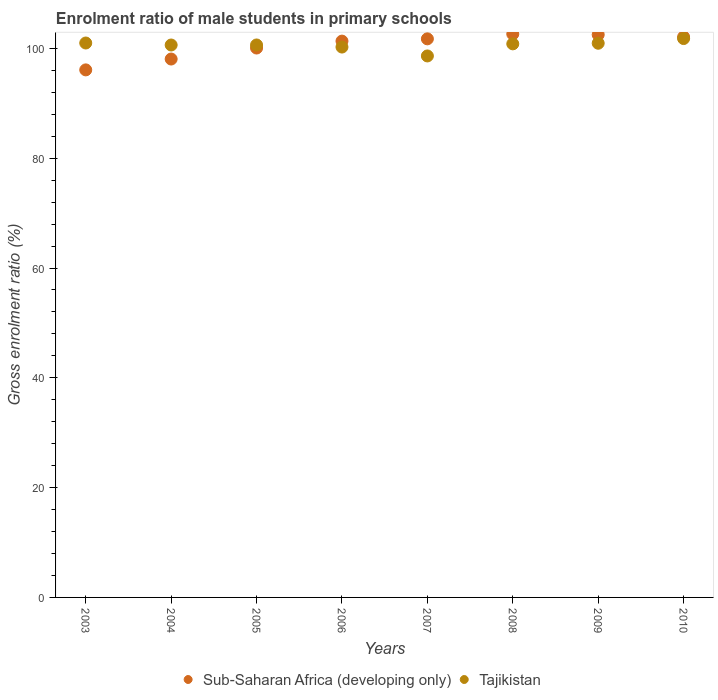How many different coloured dotlines are there?
Provide a succinct answer. 2. Is the number of dotlines equal to the number of legend labels?
Offer a very short reply. Yes. What is the enrolment ratio of male students in primary schools in Tajikistan in 2006?
Provide a short and direct response. 100.25. Across all years, what is the maximum enrolment ratio of male students in primary schools in Sub-Saharan Africa (developing only)?
Ensure brevity in your answer.  102.62. Across all years, what is the minimum enrolment ratio of male students in primary schools in Tajikistan?
Your answer should be compact. 98.63. In which year was the enrolment ratio of male students in primary schools in Sub-Saharan Africa (developing only) maximum?
Your answer should be compact. 2008. In which year was the enrolment ratio of male students in primary schools in Sub-Saharan Africa (developing only) minimum?
Make the answer very short. 2003. What is the total enrolment ratio of male students in primary schools in Tajikistan in the graph?
Provide a succinct answer. 804.71. What is the difference between the enrolment ratio of male students in primary schools in Tajikistan in 2006 and that in 2009?
Your answer should be compact. -0.69. What is the difference between the enrolment ratio of male students in primary schools in Tajikistan in 2003 and the enrolment ratio of male students in primary schools in Sub-Saharan Africa (developing only) in 2008?
Keep it short and to the point. -1.63. What is the average enrolment ratio of male students in primary schools in Sub-Saharan Africa (developing only) per year?
Make the answer very short. 100.57. In the year 2005, what is the difference between the enrolment ratio of male students in primary schools in Sub-Saharan Africa (developing only) and enrolment ratio of male students in primary schools in Tajikistan?
Your answer should be very brief. -0.56. What is the ratio of the enrolment ratio of male students in primary schools in Sub-Saharan Africa (developing only) in 2005 to that in 2008?
Ensure brevity in your answer.  0.98. Is the difference between the enrolment ratio of male students in primary schools in Sub-Saharan Africa (developing only) in 2006 and 2009 greater than the difference between the enrolment ratio of male students in primary schools in Tajikistan in 2006 and 2009?
Ensure brevity in your answer.  No. What is the difference between the highest and the second highest enrolment ratio of male students in primary schools in Tajikistan?
Your answer should be very brief. 0.81. What is the difference between the highest and the lowest enrolment ratio of male students in primary schools in Sub-Saharan Africa (developing only)?
Your answer should be very brief. 6.53. Does the enrolment ratio of male students in primary schools in Sub-Saharan Africa (developing only) monotonically increase over the years?
Your response must be concise. No. Is the enrolment ratio of male students in primary schools in Sub-Saharan Africa (developing only) strictly greater than the enrolment ratio of male students in primary schools in Tajikistan over the years?
Give a very brief answer. No. Is the enrolment ratio of male students in primary schools in Sub-Saharan Africa (developing only) strictly less than the enrolment ratio of male students in primary schools in Tajikistan over the years?
Provide a succinct answer. No. How many dotlines are there?
Ensure brevity in your answer.  2. Does the graph contain any zero values?
Offer a terse response. No. Does the graph contain grids?
Make the answer very short. No. Where does the legend appear in the graph?
Offer a terse response. Bottom center. How are the legend labels stacked?
Offer a very short reply. Horizontal. What is the title of the graph?
Offer a terse response. Enrolment ratio of male students in primary schools. Does "Rwanda" appear as one of the legend labels in the graph?
Offer a very short reply. No. What is the label or title of the Y-axis?
Your response must be concise. Gross enrolment ratio (%). What is the Gross enrolment ratio (%) of Sub-Saharan Africa (developing only) in 2003?
Your response must be concise. 96.09. What is the Gross enrolment ratio (%) in Tajikistan in 2003?
Offer a terse response. 100.99. What is the Gross enrolment ratio (%) in Sub-Saharan Africa (developing only) in 2004?
Provide a succinct answer. 98.07. What is the Gross enrolment ratio (%) of Tajikistan in 2004?
Your answer should be compact. 100.63. What is the Gross enrolment ratio (%) of Sub-Saharan Africa (developing only) in 2005?
Provide a succinct answer. 100.07. What is the Gross enrolment ratio (%) in Tajikistan in 2005?
Your response must be concise. 100.63. What is the Gross enrolment ratio (%) of Sub-Saharan Africa (developing only) in 2006?
Give a very brief answer. 101.33. What is the Gross enrolment ratio (%) in Tajikistan in 2006?
Offer a terse response. 100.25. What is the Gross enrolment ratio (%) of Sub-Saharan Africa (developing only) in 2007?
Ensure brevity in your answer.  101.75. What is the Gross enrolment ratio (%) in Tajikistan in 2007?
Provide a succinct answer. 98.63. What is the Gross enrolment ratio (%) in Sub-Saharan Africa (developing only) in 2008?
Your answer should be compact. 102.62. What is the Gross enrolment ratio (%) of Tajikistan in 2008?
Offer a very short reply. 100.83. What is the Gross enrolment ratio (%) in Sub-Saharan Africa (developing only) in 2009?
Your answer should be very brief. 102.5. What is the Gross enrolment ratio (%) in Tajikistan in 2009?
Give a very brief answer. 100.95. What is the Gross enrolment ratio (%) in Sub-Saharan Africa (developing only) in 2010?
Give a very brief answer. 102.08. What is the Gross enrolment ratio (%) in Tajikistan in 2010?
Make the answer very short. 101.8. Across all years, what is the maximum Gross enrolment ratio (%) in Sub-Saharan Africa (developing only)?
Provide a short and direct response. 102.62. Across all years, what is the maximum Gross enrolment ratio (%) in Tajikistan?
Offer a terse response. 101.8. Across all years, what is the minimum Gross enrolment ratio (%) of Sub-Saharan Africa (developing only)?
Keep it short and to the point. 96.09. Across all years, what is the minimum Gross enrolment ratio (%) in Tajikistan?
Offer a terse response. 98.63. What is the total Gross enrolment ratio (%) of Sub-Saharan Africa (developing only) in the graph?
Provide a short and direct response. 804.52. What is the total Gross enrolment ratio (%) of Tajikistan in the graph?
Make the answer very short. 804.71. What is the difference between the Gross enrolment ratio (%) of Sub-Saharan Africa (developing only) in 2003 and that in 2004?
Your response must be concise. -1.98. What is the difference between the Gross enrolment ratio (%) in Tajikistan in 2003 and that in 2004?
Offer a terse response. 0.36. What is the difference between the Gross enrolment ratio (%) of Sub-Saharan Africa (developing only) in 2003 and that in 2005?
Keep it short and to the point. -3.98. What is the difference between the Gross enrolment ratio (%) of Tajikistan in 2003 and that in 2005?
Your answer should be very brief. 0.36. What is the difference between the Gross enrolment ratio (%) in Sub-Saharan Africa (developing only) in 2003 and that in 2006?
Your answer should be compact. -5.24. What is the difference between the Gross enrolment ratio (%) of Tajikistan in 2003 and that in 2006?
Keep it short and to the point. 0.74. What is the difference between the Gross enrolment ratio (%) of Sub-Saharan Africa (developing only) in 2003 and that in 2007?
Ensure brevity in your answer.  -5.65. What is the difference between the Gross enrolment ratio (%) in Tajikistan in 2003 and that in 2007?
Provide a short and direct response. 2.36. What is the difference between the Gross enrolment ratio (%) of Sub-Saharan Africa (developing only) in 2003 and that in 2008?
Offer a terse response. -6.53. What is the difference between the Gross enrolment ratio (%) of Tajikistan in 2003 and that in 2008?
Provide a short and direct response. 0.15. What is the difference between the Gross enrolment ratio (%) of Sub-Saharan Africa (developing only) in 2003 and that in 2009?
Give a very brief answer. -6.41. What is the difference between the Gross enrolment ratio (%) of Tajikistan in 2003 and that in 2009?
Offer a very short reply. 0.04. What is the difference between the Gross enrolment ratio (%) of Sub-Saharan Africa (developing only) in 2003 and that in 2010?
Make the answer very short. -5.99. What is the difference between the Gross enrolment ratio (%) in Tajikistan in 2003 and that in 2010?
Keep it short and to the point. -0.81. What is the difference between the Gross enrolment ratio (%) in Sub-Saharan Africa (developing only) in 2004 and that in 2005?
Provide a succinct answer. -2. What is the difference between the Gross enrolment ratio (%) in Tajikistan in 2004 and that in 2005?
Your answer should be very brief. -0.01. What is the difference between the Gross enrolment ratio (%) of Sub-Saharan Africa (developing only) in 2004 and that in 2006?
Your answer should be compact. -3.26. What is the difference between the Gross enrolment ratio (%) in Tajikistan in 2004 and that in 2006?
Offer a terse response. 0.37. What is the difference between the Gross enrolment ratio (%) in Sub-Saharan Africa (developing only) in 2004 and that in 2007?
Your answer should be very brief. -3.68. What is the difference between the Gross enrolment ratio (%) of Tajikistan in 2004 and that in 2007?
Give a very brief answer. 1.99. What is the difference between the Gross enrolment ratio (%) of Sub-Saharan Africa (developing only) in 2004 and that in 2008?
Keep it short and to the point. -4.55. What is the difference between the Gross enrolment ratio (%) of Tajikistan in 2004 and that in 2008?
Your response must be concise. -0.21. What is the difference between the Gross enrolment ratio (%) in Sub-Saharan Africa (developing only) in 2004 and that in 2009?
Make the answer very short. -4.43. What is the difference between the Gross enrolment ratio (%) in Tajikistan in 2004 and that in 2009?
Provide a succinct answer. -0.32. What is the difference between the Gross enrolment ratio (%) in Sub-Saharan Africa (developing only) in 2004 and that in 2010?
Offer a terse response. -4.01. What is the difference between the Gross enrolment ratio (%) of Tajikistan in 2004 and that in 2010?
Give a very brief answer. -1.17. What is the difference between the Gross enrolment ratio (%) of Sub-Saharan Africa (developing only) in 2005 and that in 2006?
Your answer should be very brief. -1.26. What is the difference between the Gross enrolment ratio (%) of Tajikistan in 2005 and that in 2006?
Provide a succinct answer. 0.38. What is the difference between the Gross enrolment ratio (%) of Sub-Saharan Africa (developing only) in 2005 and that in 2007?
Give a very brief answer. -1.67. What is the difference between the Gross enrolment ratio (%) of Tajikistan in 2005 and that in 2007?
Your answer should be very brief. 2. What is the difference between the Gross enrolment ratio (%) of Sub-Saharan Africa (developing only) in 2005 and that in 2008?
Your response must be concise. -2.55. What is the difference between the Gross enrolment ratio (%) of Tajikistan in 2005 and that in 2008?
Your response must be concise. -0.2. What is the difference between the Gross enrolment ratio (%) of Sub-Saharan Africa (developing only) in 2005 and that in 2009?
Offer a terse response. -2.43. What is the difference between the Gross enrolment ratio (%) of Tajikistan in 2005 and that in 2009?
Offer a very short reply. -0.31. What is the difference between the Gross enrolment ratio (%) in Sub-Saharan Africa (developing only) in 2005 and that in 2010?
Provide a succinct answer. -2.01. What is the difference between the Gross enrolment ratio (%) of Tajikistan in 2005 and that in 2010?
Provide a short and direct response. -1.17. What is the difference between the Gross enrolment ratio (%) of Sub-Saharan Africa (developing only) in 2006 and that in 2007?
Give a very brief answer. -0.41. What is the difference between the Gross enrolment ratio (%) in Tajikistan in 2006 and that in 2007?
Your answer should be compact. 1.62. What is the difference between the Gross enrolment ratio (%) in Sub-Saharan Africa (developing only) in 2006 and that in 2008?
Give a very brief answer. -1.29. What is the difference between the Gross enrolment ratio (%) of Tajikistan in 2006 and that in 2008?
Give a very brief answer. -0.58. What is the difference between the Gross enrolment ratio (%) in Sub-Saharan Africa (developing only) in 2006 and that in 2009?
Provide a short and direct response. -1.17. What is the difference between the Gross enrolment ratio (%) of Tajikistan in 2006 and that in 2009?
Make the answer very short. -0.69. What is the difference between the Gross enrolment ratio (%) in Sub-Saharan Africa (developing only) in 2006 and that in 2010?
Provide a succinct answer. -0.75. What is the difference between the Gross enrolment ratio (%) of Tajikistan in 2006 and that in 2010?
Give a very brief answer. -1.55. What is the difference between the Gross enrolment ratio (%) in Sub-Saharan Africa (developing only) in 2007 and that in 2008?
Make the answer very short. -0.88. What is the difference between the Gross enrolment ratio (%) in Tajikistan in 2007 and that in 2008?
Give a very brief answer. -2.2. What is the difference between the Gross enrolment ratio (%) of Sub-Saharan Africa (developing only) in 2007 and that in 2009?
Offer a terse response. -0.76. What is the difference between the Gross enrolment ratio (%) in Tajikistan in 2007 and that in 2009?
Offer a very short reply. -2.31. What is the difference between the Gross enrolment ratio (%) of Sub-Saharan Africa (developing only) in 2007 and that in 2010?
Offer a terse response. -0.33. What is the difference between the Gross enrolment ratio (%) of Tajikistan in 2007 and that in 2010?
Keep it short and to the point. -3.17. What is the difference between the Gross enrolment ratio (%) in Sub-Saharan Africa (developing only) in 2008 and that in 2009?
Offer a very short reply. 0.12. What is the difference between the Gross enrolment ratio (%) in Tajikistan in 2008 and that in 2009?
Ensure brevity in your answer.  -0.11. What is the difference between the Gross enrolment ratio (%) of Sub-Saharan Africa (developing only) in 2008 and that in 2010?
Ensure brevity in your answer.  0.54. What is the difference between the Gross enrolment ratio (%) of Tajikistan in 2008 and that in 2010?
Provide a succinct answer. -0.97. What is the difference between the Gross enrolment ratio (%) in Sub-Saharan Africa (developing only) in 2009 and that in 2010?
Provide a succinct answer. 0.42. What is the difference between the Gross enrolment ratio (%) of Tajikistan in 2009 and that in 2010?
Keep it short and to the point. -0.85. What is the difference between the Gross enrolment ratio (%) in Sub-Saharan Africa (developing only) in 2003 and the Gross enrolment ratio (%) in Tajikistan in 2004?
Your response must be concise. -4.53. What is the difference between the Gross enrolment ratio (%) in Sub-Saharan Africa (developing only) in 2003 and the Gross enrolment ratio (%) in Tajikistan in 2005?
Keep it short and to the point. -4.54. What is the difference between the Gross enrolment ratio (%) in Sub-Saharan Africa (developing only) in 2003 and the Gross enrolment ratio (%) in Tajikistan in 2006?
Offer a very short reply. -4.16. What is the difference between the Gross enrolment ratio (%) of Sub-Saharan Africa (developing only) in 2003 and the Gross enrolment ratio (%) of Tajikistan in 2007?
Your answer should be very brief. -2.54. What is the difference between the Gross enrolment ratio (%) in Sub-Saharan Africa (developing only) in 2003 and the Gross enrolment ratio (%) in Tajikistan in 2008?
Provide a short and direct response. -4.74. What is the difference between the Gross enrolment ratio (%) in Sub-Saharan Africa (developing only) in 2003 and the Gross enrolment ratio (%) in Tajikistan in 2009?
Keep it short and to the point. -4.85. What is the difference between the Gross enrolment ratio (%) of Sub-Saharan Africa (developing only) in 2003 and the Gross enrolment ratio (%) of Tajikistan in 2010?
Your answer should be compact. -5.71. What is the difference between the Gross enrolment ratio (%) in Sub-Saharan Africa (developing only) in 2004 and the Gross enrolment ratio (%) in Tajikistan in 2005?
Make the answer very short. -2.56. What is the difference between the Gross enrolment ratio (%) in Sub-Saharan Africa (developing only) in 2004 and the Gross enrolment ratio (%) in Tajikistan in 2006?
Provide a succinct answer. -2.18. What is the difference between the Gross enrolment ratio (%) in Sub-Saharan Africa (developing only) in 2004 and the Gross enrolment ratio (%) in Tajikistan in 2007?
Offer a very short reply. -0.56. What is the difference between the Gross enrolment ratio (%) of Sub-Saharan Africa (developing only) in 2004 and the Gross enrolment ratio (%) of Tajikistan in 2008?
Your response must be concise. -2.77. What is the difference between the Gross enrolment ratio (%) in Sub-Saharan Africa (developing only) in 2004 and the Gross enrolment ratio (%) in Tajikistan in 2009?
Your answer should be compact. -2.88. What is the difference between the Gross enrolment ratio (%) in Sub-Saharan Africa (developing only) in 2004 and the Gross enrolment ratio (%) in Tajikistan in 2010?
Your answer should be very brief. -3.73. What is the difference between the Gross enrolment ratio (%) of Sub-Saharan Africa (developing only) in 2005 and the Gross enrolment ratio (%) of Tajikistan in 2006?
Ensure brevity in your answer.  -0.18. What is the difference between the Gross enrolment ratio (%) in Sub-Saharan Africa (developing only) in 2005 and the Gross enrolment ratio (%) in Tajikistan in 2007?
Ensure brevity in your answer.  1.44. What is the difference between the Gross enrolment ratio (%) of Sub-Saharan Africa (developing only) in 2005 and the Gross enrolment ratio (%) of Tajikistan in 2008?
Your response must be concise. -0.76. What is the difference between the Gross enrolment ratio (%) in Sub-Saharan Africa (developing only) in 2005 and the Gross enrolment ratio (%) in Tajikistan in 2009?
Make the answer very short. -0.87. What is the difference between the Gross enrolment ratio (%) in Sub-Saharan Africa (developing only) in 2005 and the Gross enrolment ratio (%) in Tajikistan in 2010?
Make the answer very short. -1.73. What is the difference between the Gross enrolment ratio (%) of Sub-Saharan Africa (developing only) in 2006 and the Gross enrolment ratio (%) of Tajikistan in 2007?
Give a very brief answer. 2.7. What is the difference between the Gross enrolment ratio (%) of Sub-Saharan Africa (developing only) in 2006 and the Gross enrolment ratio (%) of Tajikistan in 2008?
Make the answer very short. 0.5. What is the difference between the Gross enrolment ratio (%) of Sub-Saharan Africa (developing only) in 2006 and the Gross enrolment ratio (%) of Tajikistan in 2009?
Provide a succinct answer. 0.39. What is the difference between the Gross enrolment ratio (%) of Sub-Saharan Africa (developing only) in 2006 and the Gross enrolment ratio (%) of Tajikistan in 2010?
Offer a terse response. -0.47. What is the difference between the Gross enrolment ratio (%) of Sub-Saharan Africa (developing only) in 2007 and the Gross enrolment ratio (%) of Tajikistan in 2008?
Ensure brevity in your answer.  0.91. What is the difference between the Gross enrolment ratio (%) in Sub-Saharan Africa (developing only) in 2007 and the Gross enrolment ratio (%) in Tajikistan in 2009?
Keep it short and to the point. 0.8. What is the difference between the Gross enrolment ratio (%) in Sub-Saharan Africa (developing only) in 2007 and the Gross enrolment ratio (%) in Tajikistan in 2010?
Provide a short and direct response. -0.05. What is the difference between the Gross enrolment ratio (%) in Sub-Saharan Africa (developing only) in 2008 and the Gross enrolment ratio (%) in Tajikistan in 2009?
Your answer should be very brief. 1.68. What is the difference between the Gross enrolment ratio (%) in Sub-Saharan Africa (developing only) in 2008 and the Gross enrolment ratio (%) in Tajikistan in 2010?
Your answer should be very brief. 0.82. What is the difference between the Gross enrolment ratio (%) of Sub-Saharan Africa (developing only) in 2009 and the Gross enrolment ratio (%) of Tajikistan in 2010?
Provide a short and direct response. 0.7. What is the average Gross enrolment ratio (%) in Sub-Saharan Africa (developing only) per year?
Your answer should be compact. 100.57. What is the average Gross enrolment ratio (%) in Tajikistan per year?
Your response must be concise. 100.59. In the year 2003, what is the difference between the Gross enrolment ratio (%) of Sub-Saharan Africa (developing only) and Gross enrolment ratio (%) of Tajikistan?
Keep it short and to the point. -4.89. In the year 2004, what is the difference between the Gross enrolment ratio (%) of Sub-Saharan Africa (developing only) and Gross enrolment ratio (%) of Tajikistan?
Keep it short and to the point. -2.56. In the year 2005, what is the difference between the Gross enrolment ratio (%) of Sub-Saharan Africa (developing only) and Gross enrolment ratio (%) of Tajikistan?
Keep it short and to the point. -0.56. In the year 2006, what is the difference between the Gross enrolment ratio (%) of Sub-Saharan Africa (developing only) and Gross enrolment ratio (%) of Tajikistan?
Offer a terse response. 1.08. In the year 2007, what is the difference between the Gross enrolment ratio (%) of Sub-Saharan Africa (developing only) and Gross enrolment ratio (%) of Tajikistan?
Keep it short and to the point. 3.12. In the year 2008, what is the difference between the Gross enrolment ratio (%) in Sub-Saharan Africa (developing only) and Gross enrolment ratio (%) in Tajikistan?
Provide a short and direct response. 1.79. In the year 2009, what is the difference between the Gross enrolment ratio (%) in Sub-Saharan Africa (developing only) and Gross enrolment ratio (%) in Tajikistan?
Offer a very short reply. 1.56. In the year 2010, what is the difference between the Gross enrolment ratio (%) in Sub-Saharan Africa (developing only) and Gross enrolment ratio (%) in Tajikistan?
Your answer should be compact. 0.28. What is the ratio of the Gross enrolment ratio (%) in Sub-Saharan Africa (developing only) in 2003 to that in 2004?
Ensure brevity in your answer.  0.98. What is the ratio of the Gross enrolment ratio (%) in Tajikistan in 2003 to that in 2004?
Offer a terse response. 1. What is the ratio of the Gross enrolment ratio (%) in Sub-Saharan Africa (developing only) in 2003 to that in 2005?
Offer a very short reply. 0.96. What is the ratio of the Gross enrolment ratio (%) in Sub-Saharan Africa (developing only) in 2003 to that in 2006?
Your answer should be compact. 0.95. What is the ratio of the Gross enrolment ratio (%) of Tajikistan in 2003 to that in 2006?
Ensure brevity in your answer.  1.01. What is the ratio of the Gross enrolment ratio (%) of Sub-Saharan Africa (developing only) in 2003 to that in 2007?
Offer a very short reply. 0.94. What is the ratio of the Gross enrolment ratio (%) in Tajikistan in 2003 to that in 2007?
Your response must be concise. 1.02. What is the ratio of the Gross enrolment ratio (%) in Sub-Saharan Africa (developing only) in 2003 to that in 2008?
Provide a succinct answer. 0.94. What is the ratio of the Gross enrolment ratio (%) in Tajikistan in 2003 to that in 2008?
Your answer should be compact. 1. What is the ratio of the Gross enrolment ratio (%) of Sub-Saharan Africa (developing only) in 2003 to that in 2009?
Make the answer very short. 0.94. What is the ratio of the Gross enrolment ratio (%) of Sub-Saharan Africa (developing only) in 2003 to that in 2010?
Offer a terse response. 0.94. What is the ratio of the Gross enrolment ratio (%) of Tajikistan in 2003 to that in 2010?
Offer a very short reply. 0.99. What is the ratio of the Gross enrolment ratio (%) of Sub-Saharan Africa (developing only) in 2004 to that in 2005?
Make the answer very short. 0.98. What is the ratio of the Gross enrolment ratio (%) of Tajikistan in 2004 to that in 2005?
Your answer should be compact. 1. What is the ratio of the Gross enrolment ratio (%) of Sub-Saharan Africa (developing only) in 2004 to that in 2006?
Offer a terse response. 0.97. What is the ratio of the Gross enrolment ratio (%) in Tajikistan in 2004 to that in 2006?
Offer a terse response. 1. What is the ratio of the Gross enrolment ratio (%) in Sub-Saharan Africa (developing only) in 2004 to that in 2007?
Provide a short and direct response. 0.96. What is the ratio of the Gross enrolment ratio (%) in Tajikistan in 2004 to that in 2007?
Your answer should be compact. 1.02. What is the ratio of the Gross enrolment ratio (%) of Sub-Saharan Africa (developing only) in 2004 to that in 2008?
Your answer should be compact. 0.96. What is the ratio of the Gross enrolment ratio (%) in Tajikistan in 2004 to that in 2008?
Give a very brief answer. 1. What is the ratio of the Gross enrolment ratio (%) in Sub-Saharan Africa (developing only) in 2004 to that in 2009?
Ensure brevity in your answer.  0.96. What is the ratio of the Gross enrolment ratio (%) of Sub-Saharan Africa (developing only) in 2004 to that in 2010?
Give a very brief answer. 0.96. What is the ratio of the Gross enrolment ratio (%) of Tajikistan in 2004 to that in 2010?
Your answer should be compact. 0.99. What is the ratio of the Gross enrolment ratio (%) of Sub-Saharan Africa (developing only) in 2005 to that in 2006?
Make the answer very short. 0.99. What is the ratio of the Gross enrolment ratio (%) in Tajikistan in 2005 to that in 2006?
Offer a very short reply. 1. What is the ratio of the Gross enrolment ratio (%) in Sub-Saharan Africa (developing only) in 2005 to that in 2007?
Offer a terse response. 0.98. What is the ratio of the Gross enrolment ratio (%) of Tajikistan in 2005 to that in 2007?
Offer a terse response. 1.02. What is the ratio of the Gross enrolment ratio (%) in Sub-Saharan Africa (developing only) in 2005 to that in 2008?
Give a very brief answer. 0.98. What is the ratio of the Gross enrolment ratio (%) of Tajikistan in 2005 to that in 2008?
Your answer should be compact. 1. What is the ratio of the Gross enrolment ratio (%) of Sub-Saharan Africa (developing only) in 2005 to that in 2009?
Provide a short and direct response. 0.98. What is the ratio of the Gross enrolment ratio (%) in Sub-Saharan Africa (developing only) in 2005 to that in 2010?
Give a very brief answer. 0.98. What is the ratio of the Gross enrolment ratio (%) of Sub-Saharan Africa (developing only) in 2006 to that in 2007?
Offer a very short reply. 1. What is the ratio of the Gross enrolment ratio (%) in Tajikistan in 2006 to that in 2007?
Your answer should be very brief. 1.02. What is the ratio of the Gross enrolment ratio (%) in Sub-Saharan Africa (developing only) in 2006 to that in 2008?
Offer a terse response. 0.99. What is the ratio of the Gross enrolment ratio (%) of Tajikistan in 2006 to that in 2008?
Offer a very short reply. 0.99. What is the ratio of the Gross enrolment ratio (%) in Sub-Saharan Africa (developing only) in 2006 to that in 2009?
Offer a very short reply. 0.99. What is the ratio of the Gross enrolment ratio (%) of Tajikistan in 2006 to that in 2009?
Provide a succinct answer. 0.99. What is the ratio of the Gross enrolment ratio (%) of Sub-Saharan Africa (developing only) in 2006 to that in 2010?
Make the answer very short. 0.99. What is the ratio of the Gross enrolment ratio (%) in Sub-Saharan Africa (developing only) in 2007 to that in 2008?
Your answer should be compact. 0.99. What is the ratio of the Gross enrolment ratio (%) in Tajikistan in 2007 to that in 2008?
Keep it short and to the point. 0.98. What is the ratio of the Gross enrolment ratio (%) of Tajikistan in 2007 to that in 2009?
Offer a terse response. 0.98. What is the ratio of the Gross enrolment ratio (%) of Sub-Saharan Africa (developing only) in 2007 to that in 2010?
Offer a terse response. 1. What is the ratio of the Gross enrolment ratio (%) of Tajikistan in 2007 to that in 2010?
Keep it short and to the point. 0.97. What is the ratio of the Gross enrolment ratio (%) in Sub-Saharan Africa (developing only) in 2008 to that in 2009?
Your response must be concise. 1. What is the ratio of the Gross enrolment ratio (%) in Tajikistan in 2008 to that in 2009?
Your response must be concise. 1. What is the ratio of the Gross enrolment ratio (%) in Tajikistan in 2008 to that in 2010?
Offer a terse response. 0.99. What is the ratio of the Gross enrolment ratio (%) of Tajikistan in 2009 to that in 2010?
Keep it short and to the point. 0.99. What is the difference between the highest and the second highest Gross enrolment ratio (%) in Sub-Saharan Africa (developing only)?
Provide a succinct answer. 0.12. What is the difference between the highest and the second highest Gross enrolment ratio (%) of Tajikistan?
Your response must be concise. 0.81. What is the difference between the highest and the lowest Gross enrolment ratio (%) of Sub-Saharan Africa (developing only)?
Offer a very short reply. 6.53. What is the difference between the highest and the lowest Gross enrolment ratio (%) of Tajikistan?
Make the answer very short. 3.17. 